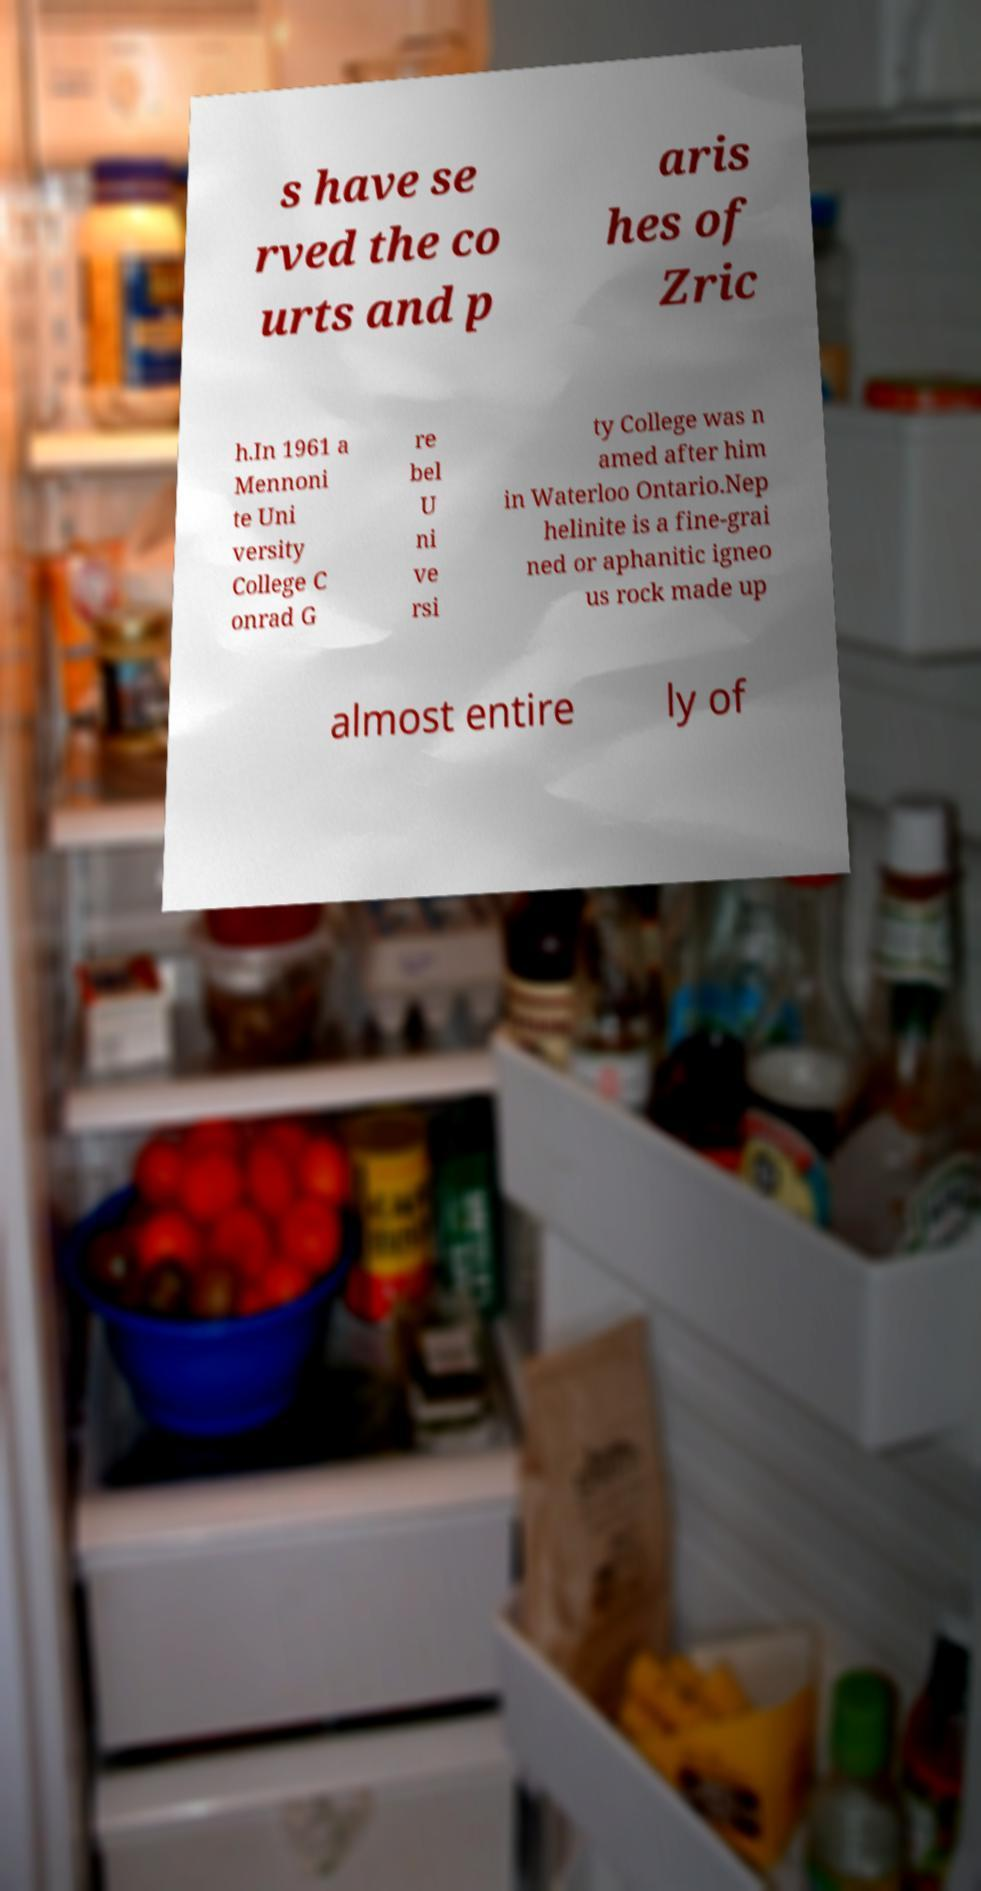Please identify and transcribe the text found in this image. s have se rved the co urts and p aris hes of Zric h.In 1961 a Mennoni te Uni versity College C onrad G re bel U ni ve rsi ty College was n amed after him in Waterloo Ontario.Nep helinite is a fine-grai ned or aphanitic igneo us rock made up almost entire ly of 